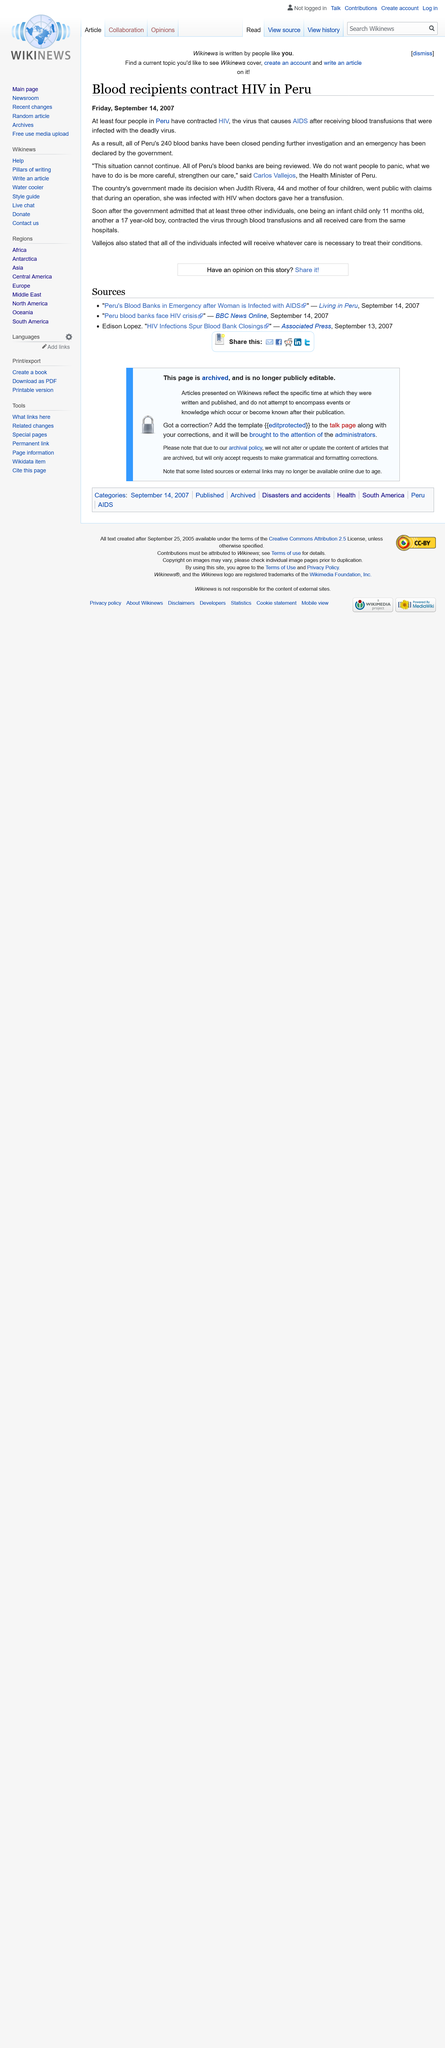Give some essential details in this illustration. Carlos Vallejos is the current Health Minister of Peru. At least four individuals in Peru have contracted HIV after receiving infected blood transfusions, according to recent reports. Judith Rivera and three other individuals, including a 17 year old boy and an 11 month old child, were infected with HIV as a result of receiving blood transfusions. 